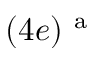<formula> <loc_0><loc_0><loc_500><loc_500>( 4 e ) ^ { a }</formula> 